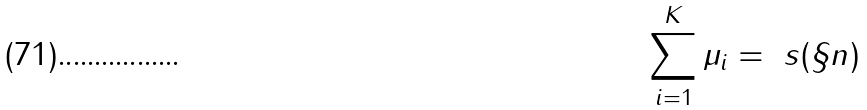Convert formula to latex. <formula><loc_0><loc_0><loc_500><loc_500>\sum _ { i = 1 } ^ { K } \mu _ { i } = \ s ( \S n )</formula> 